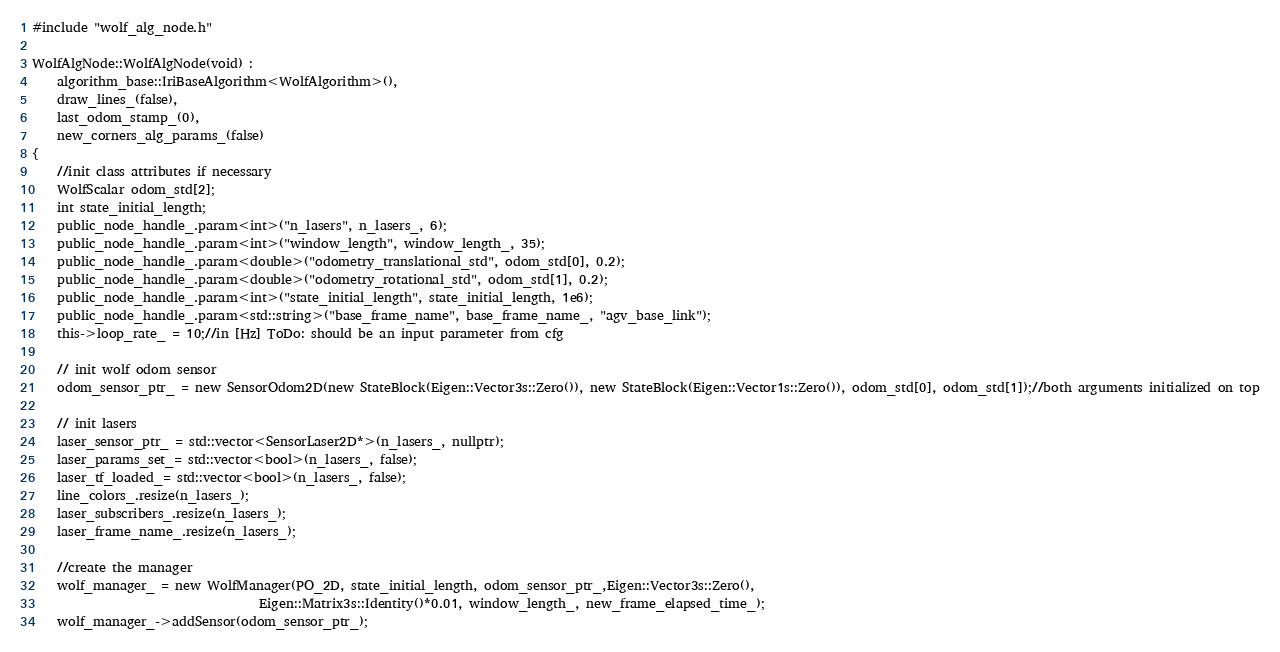Convert code to text. <code><loc_0><loc_0><loc_500><loc_500><_C++_>#include "wolf_alg_node.h"

WolfAlgNode::WolfAlgNode(void) :
    algorithm_base::IriBaseAlgorithm<WolfAlgorithm>(),
    draw_lines_(false),
    last_odom_stamp_(0),
    new_corners_alg_params_(false)
{
    //init class attributes if necessary
    WolfScalar odom_std[2];
    int state_initial_length;
    public_node_handle_.param<int>("n_lasers", n_lasers_, 6);
    public_node_handle_.param<int>("window_length", window_length_, 35);
    public_node_handle_.param<double>("odometry_translational_std", odom_std[0], 0.2);
    public_node_handle_.param<double>("odometry_rotational_std", odom_std[1], 0.2);
    public_node_handle_.param<int>("state_initial_length", state_initial_length, 1e6);
    public_node_handle_.param<std::string>("base_frame_name", base_frame_name_, "agv_base_link");
    this->loop_rate_ = 10;//in [Hz] ToDo: should be an input parameter from cfg
 
    // init wolf odom sensor 
    odom_sensor_ptr_ = new SensorOdom2D(new StateBlock(Eigen::Vector3s::Zero()), new StateBlock(Eigen::Vector1s::Zero()), odom_std[0], odom_std[1]);//both arguments initialized on top

    // init lasers
    laser_sensor_ptr_ = std::vector<SensorLaser2D*>(n_lasers_, nullptr);
    laser_params_set_= std::vector<bool>(n_lasers_, false);
    laser_tf_loaded_= std::vector<bool>(n_lasers_, false);
    line_colors_.resize(n_lasers_);
    laser_subscribers_.resize(n_lasers_);
    laser_frame_name_.resize(n_lasers_);

    //create the manager
    wolf_manager_ = new WolfManager(PO_2D, state_initial_length, odom_sensor_ptr_,Eigen::Vector3s::Zero(),
                                    Eigen::Matrix3s::Identity()*0.01, window_length_, new_frame_elapsed_time_);
    wolf_manager_->addSensor(odom_sensor_ptr_);
</code> 